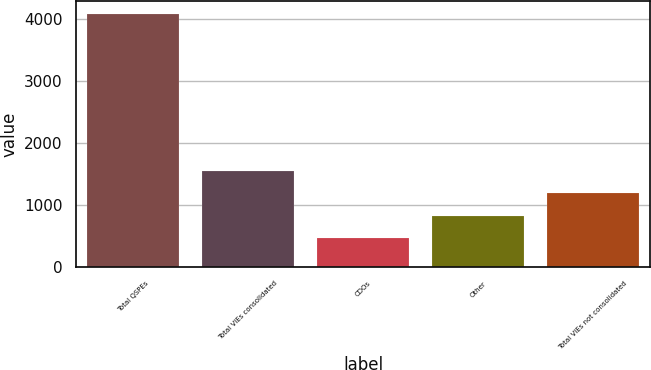<chart> <loc_0><loc_0><loc_500><loc_500><bar_chart><fcel>Total QSPEs<fcel>Total VIEs consolidated<fcel>CDOs<fcel>Other<fcel>Total VIEs not consolidated<nl><fcel>4089<fcel>1551.5<fcel>464<fcel>826.5<fcel>1189<nl></chart> 